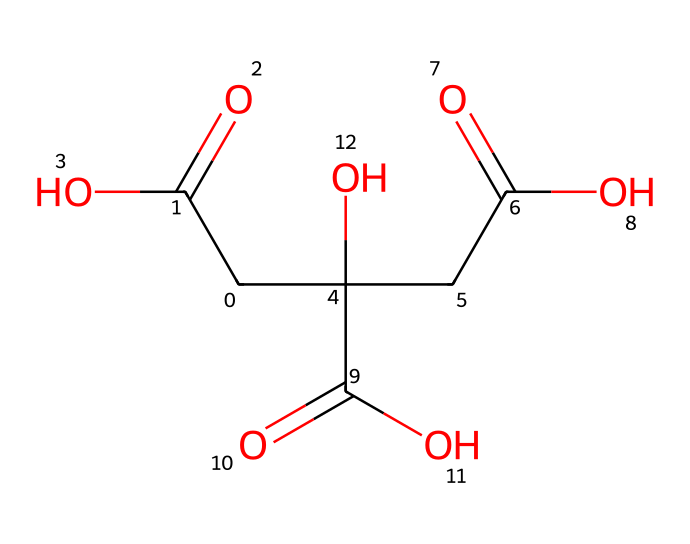What is the total number of carbon atoms in the structure? Upon examining the SMILES representation, we can count the occurrence of carbon atoms. The structure indicates the presence of five carbon atoms.
Answer: five How many carboxylic acid groups are present? The structure contains multiple parts with the carboxylic acid functional group (-COOH). By analyzing the representation, we find that there are three carboxylic acid groups.
Answer: three What is the primary functional group present in this chemical? Observing the structure, we identify that the carboxylic acid groups are the most prominent functional groups in this chemical, characterizing it as an acid.
Answer: carboxylic acid Which type of polymer is suggested by this structure? The presence of repeating units and carboxylic acids in the SMILES representation indicates that this chemical is likely a type of polyester, as polyesters are formed from the reaction of diacids and diols.
Answer: polyester Is this compound likely to be biodegradable? Given that the structure consists of multiple carboxylic acid groups and is indicative of a polymer (likely a biodegradable polymer), it suggests a higher likelihood of biodegradability compared to traditional plastics.
Answer: yes What physical property is often associated with biodegradable plastics like this? Biodegradable plastics are typically associated with having lower mechanical strength compared to conventional plastics, which makes them suitable for applications where environmental impact is a concern over durability.
Answer: lower mechanical strength 